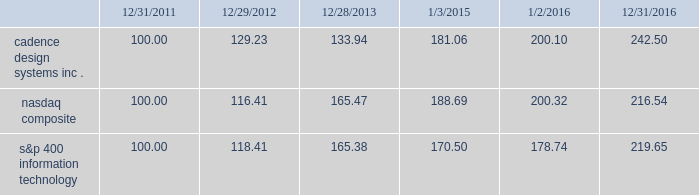Stockholder return performance graph the following graph compares the cumulative 5-year total stockholder return on our common stock relative to the cumulative total return of the nasdaq composite index and the s&p 400 information technology index .
The graph assumes that the value of the investment in our common stock and in each index on december 31 , 2011 ( including reinvestment of dividends ) was $ 100 and tracks it each year thereafter on the last day of our fiscal year through december 31 , 2016 and , for each index , on the last day of the calendar year .
Comparison of 5 year cumulative total return* among cadence design systems , inc. , the nasdaq composite index , and s&p 400 information technology cadence design systems , inc .
Nasdaq composite s&p 400 information technology 12/31/1612/28/13 1/2/1612/31/11 1/3/1512/29/12 *$ 100 invested on 12/31/11 in stock or index , including reinvestment of dividends .
Indexes calculated on month-end basis .
Copyright a9 2017 standard & poor 2019s , a division of s&p global .
All rights reserved. .
The stock price performance included in this graph is not necessarily indicative of future stock price performance. .
What was the percentage cumulative 5-year total stockholder return on cadence design systems inc . common stock for the period ended 12/31/2016? 
Computations: ((242.50 - 100) / 100)
Answer: 1.425. 